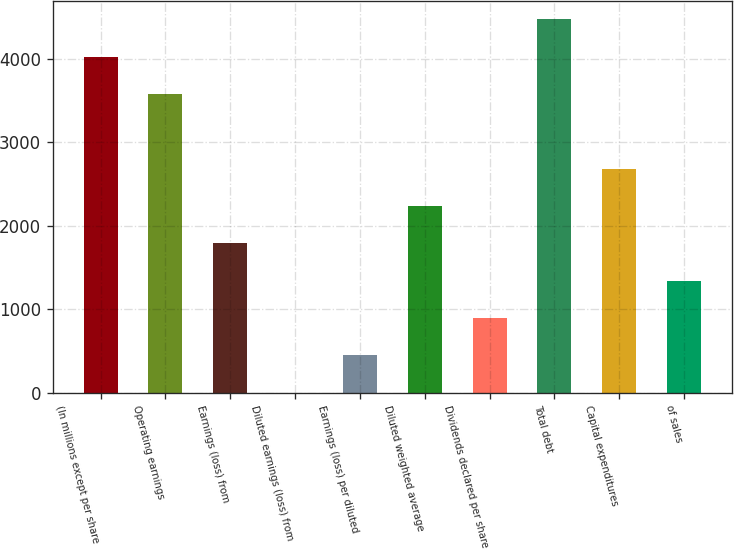Convert chart. <chart><loc_0><loc_0><loc_500><loc_500><bar_chart><fcel>(In millions except per share<fcel>Operating earnings<fcel>Earnings (loss) from<fcel>Diluted earnings (loss) from<fcel>Earnings (loss) per diluted<fcel>Diluted weighted average<fcel>Dividends declared per share<fcel>Total debt<fcel>Capital expenditures<fcel>of sales<nl><fcel>4023.99<fcel>3576.99<fcel>1788.99<fcel>0.95<fcel>447.96<fcel>2235.99<fcel>894.97<fcel>4471<fcel>2682.99<fcel>1341.98<nl></chart> 